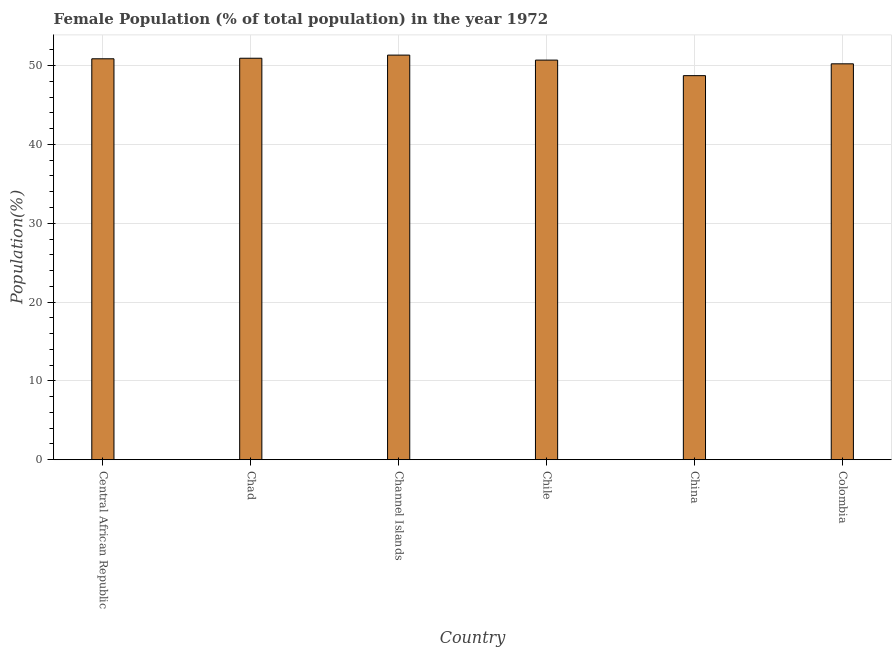Does the graph contain any zero values?
Your answer should be very brief. No. Does the graph contain grids?
Provide a succinct answer. Yes. What is the title of the graph?
Offer a very short reply. Female Population (% of total population) in the year 1972. What is the label or title of the Y-axis?
Give a very brief answer. Population(%). What is the female population in Chile?
Provide a succinct answer. 50.7. Across all countries, what is the maximum female population?
Make the answer very short. 51.33. Across all countries, what is the minimum female population?
Offer a very short reply. 48.73. In which country was the female population maximum?
Your response must be concise. Channel Islands. In which country was the female population minimum?
Offer a very short reply. China. What is the sum of the female population?
Keep it short and to the point. 302.79. What is the difference between the female population in Channel Islands and Chile?
Your response must be concise. 0.64. What is the average female population per country?
Your response must be concise. 50.47. What is the median female population?
Offer a terse response. 50.78. In how many countries, is the female population greater than 30 %?
Give a very brief answer. 6. What is the ratio of the female population in Chile to that in Colombia?
Your answer should be very brief. 1.01. Is the difference between the female population in Chile and Colombia greater than the difference between any two countries?
Provide a short and direct response. No. What is the difference between the highest and the second highest female population?
Your answer should be compact. 0.4. Is the sum of the female population in Channel Islands and Colombia greater than the maximum female population across all countries?
Your response must be concise. Yes. What is the difference between the highest and the lowest female population?
Your response must be concise. 2.61. In how many countries, is the female population greater than the average female population taken over all countries?
Make the answer very short. 4. How many countries are there in the graph?
Your answer should be very brief. 6. What is the Population(%) in Central African Republic?
Your answer should be very brief. 50.87. What is the Population(%) of Chad?
Offer a terse response. 50.94. What is the Population(%) in Channel Islands?
Your answer should be compact. 51.33. What is the Population(%) of Chile?
Give a very brief answer. 50.7. What is the Population(%) in China?
Your response must be concise. 48.73. What is the Population(%) of Colombia?
Your response must be concise. 50.23. What is the difference between the Population(%) in Central African Republic and Chad?
Your answer should be compact. -0.07. What is the difference between the Population(%) in Central African Republic and Channel Islands?
Ensure brevity in your answer.  -0.47. What is the difference between the Population(%) in Central African Republic and Chile?
Offer a very short reply. 0.17. What is the difference between the Population(%) in Central African Republic and China?
Your answer should be compact. 2.14. What is the difference between the Population(%) in Central African Republic and Colombia?
Give a very brief answer. 0.64. What is the difference between the Population(%) in Chad and Channel Islands?
Offer a very short reply. -0.4. What is the difference between the Population(%) in Chad and Chile?
Ensure brevity in your answer.  0.24. What is the difference between the Population(%) in Chad and China?
Offer a very short reply. 2.21. What is the difference between the Population(%) in Chad and Colombia?
Provide a succinct answer. 0.71. What is the difference between the Population(%) in Channel Islands and Chile?
Your response must be concise. 0.63. What is the difference between the Population(%) in Channel Islands and China?
Provide a succinct answer. 2.61. What is the difference between the Population(%) in Channel Islands and Colombia?
Make the answer very short. 1.11. What is the difference between the Population(%) in Chile and China?
Make the answer very short. 1.97. What is the difference between the Population(%) in Chile and Colombia?
Keep it short and to the point. 0.47. What is the difference between the Population(%) in China and Colombia?
Provide a short and direct response. -1.5. What is the ratio of the Population(%) in Central African Republic to that in Channel Islands?
Offer a very short reply. 0.99. What is the ratio of the Population(%) in Central African Republic to that in China?
Offer a very short reply. 1.04. What is the ratio of the Population(%) in Chad to that in Channel Islands?
Your response must be concise. 0.99. What is the ratio of the Population(%) in Chad to that in Chile?
Make the answer very short. 1. What is the ratio of the Population(%) in Chad to that in China?
Give a very brief answer. 1.04. What is the ratio of the Population(%) in Channel Islands to that in China?
Your response must be concise. 1.05. What is the ratio of the Population(%) in Chile to that in China?
Your answer should be compact. 1.04. What is the ratio of the Population(%) in China to that in Colombia?
Your answer should be very brief. 0.97. 